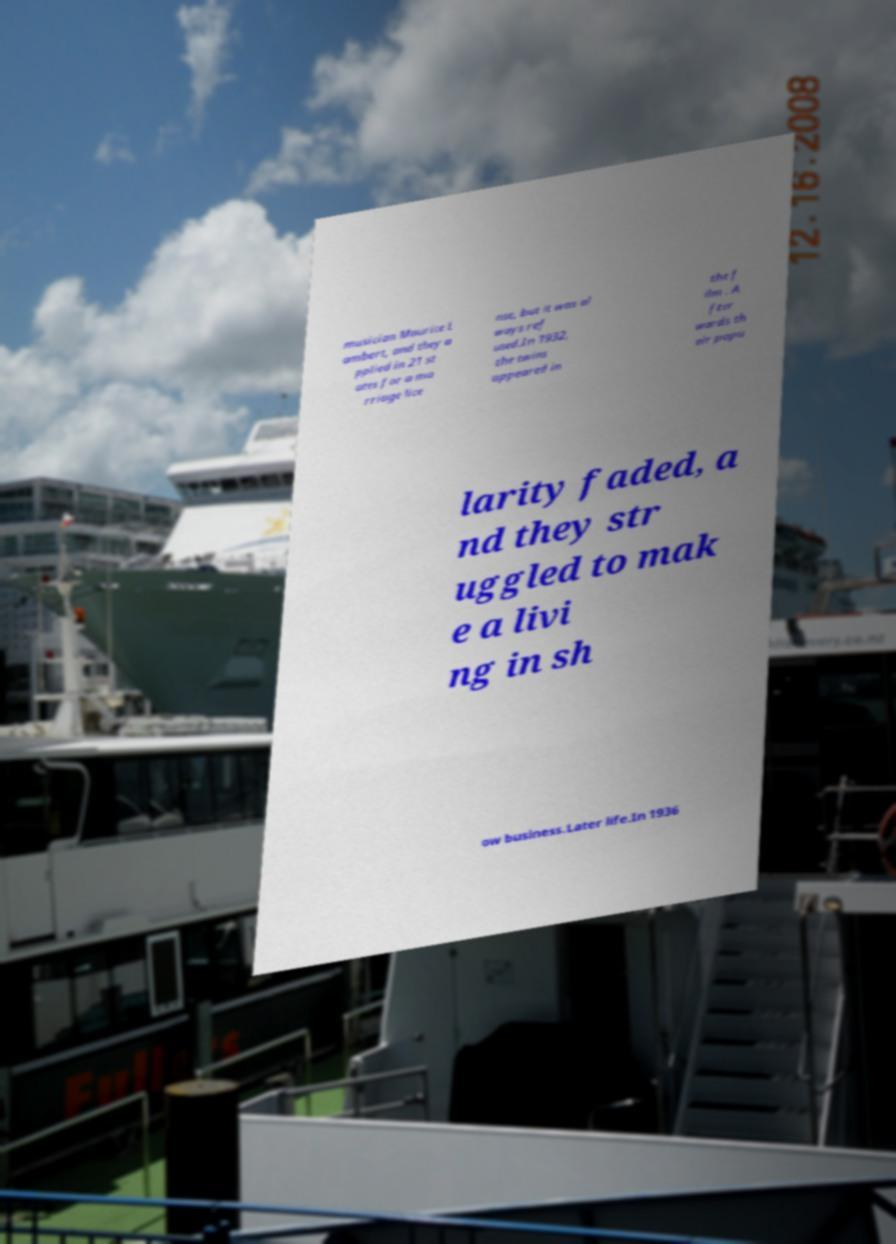What messages or text are displayed in this image? I need them in a readable, typed format. musician Maurice L ambert, and they a pplied in 21 st ates for a ma rriage lice nse, but it was al ways ref used.In 1932, the twins appeared in the f ilm . A fter wards th eir popu larity faded, a nd they str uggled to mak e a livi ng in sh ow business.Later life.In 1936 